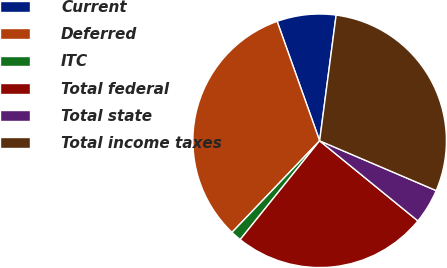Convert chart. <chart><loc_0><loc_0><loc_500><loc_500><pie_chart><fcel>Current<fcel>Deferred<fcel>ITC<fcel>Total federal<fcel>Total state<fcel>Total income taxes<nl><fcel>7.52%<fcel>32.41%<fcel>1.37%<fcel>24.89%<fcel>4.46%<fcel>29.35%<nl></chart> 